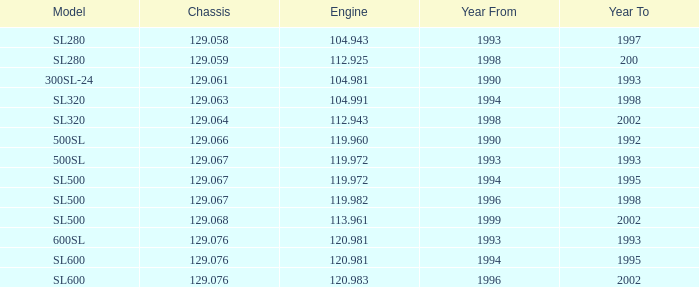For an sl500 model with a year of production exceeding 1999, which engine is used? None. 